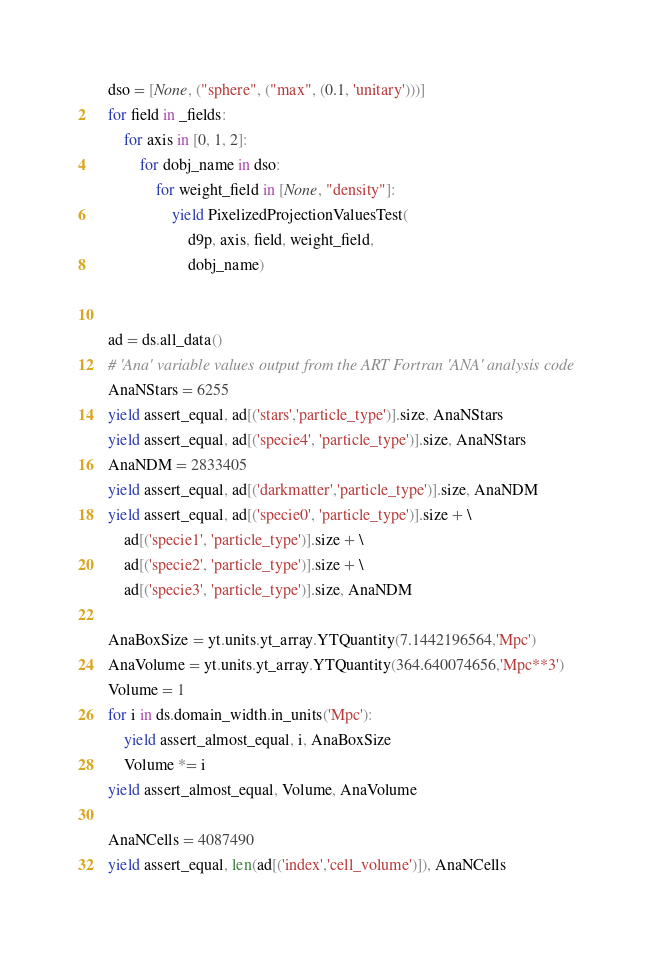Convert code to text. <code><loc_0><loc_0><loc_500><loc_500><_Python_>    dso = [None, ("sphere", ("max", (0.1, 'unitary')))]
    for field in _fields:
        for axis in [0, 1, 2]:
            for dobj_name in dso:
                for weight_field in [None, "density"]:
                    yield PixelizedProjectionValuesTest(
                        d9p, axis, field, weight_field,
                        dobj_name)


    ad = ds.all_data()
    # 'Ana' variable values output from the ART Fortran 'ANA' analysis code
    AnaNStars = 6255
    yield assert_equal, ad[('stars','particle_type')].size, AnaNStars
    yield assert_equal, ad[('specie4', 'particle_type')].size, AnaNStars
    AnaNDM = 2833405
    yield assert_equal, ad[('darkmatter','particle_type')].size, AnaNDM
    yield assert_equal, ad[('specie0', 'particle_type')].size + \
        ad[('specie1', 'particle_type')].size + \
        ad[('specie2', 'particle_type')].size + \
        ad[('specie3', 'particle_type')].size, AnaNDM

    AnaBoxSize = yt.units.yt_array.YTQuantity(7.1442196564,'Mpc')
    AnaVolume = yt.units.yt_array.YTQuantity(364.640074656,'Mpc**3')
    Volume = 1
    for i in ds.domain_width.in_units('Mpc'):
        yield assert_almost_equal, i, AnaBoxSize
        Volume *= i
    yield assert_almost_equal, Volume, AnaVolume

    AnaNCells = 4087490
    yield assert_equal, len(ad[('index','cell_volume')]), AnaNCells
</code> 